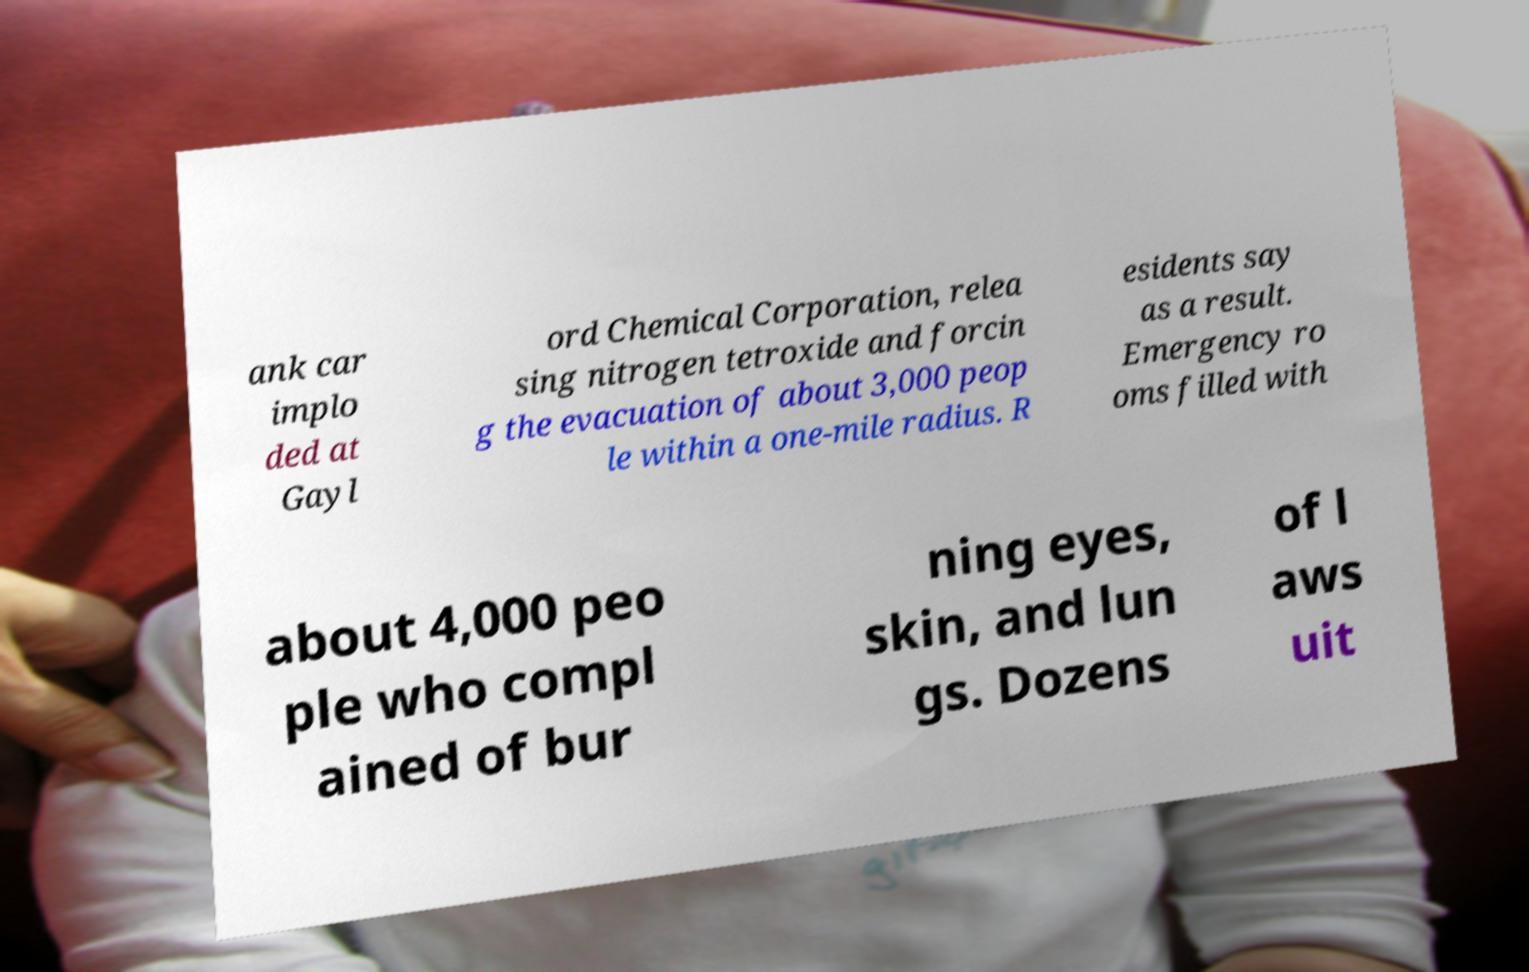Please read and relay the text visible in this image. What does it say? ank car implo ded at Gayl ord Chemical Corporation, relea sing nitrogen tetroxide and forcin g the evacuation of about 3,000 peop le within a one-mile radius. R esidents say as a result. Emergency ro oms filled with about 4,000 peo ple who compl ained of bur ning eyes, skin, and lun gs. Dozens of l aws uit 